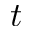<formula> <loc_0><loc_0><loc_500><loc_500>t</formula> 